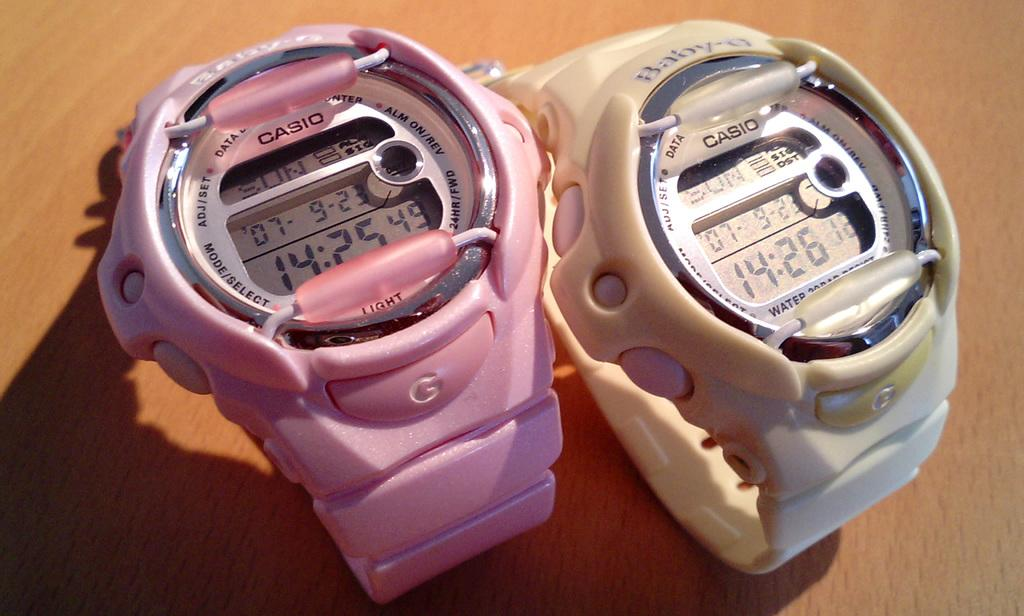<image>
Relay a brief, clear account of the picture shown. Two Casio watches are side by side and one is pink. 